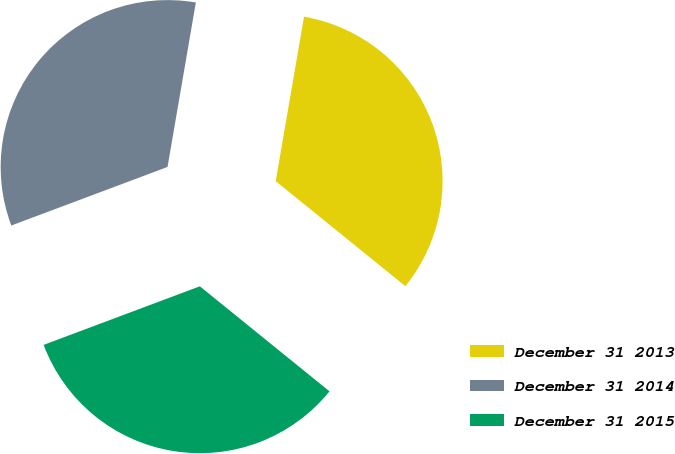Convert chart to OTSL. <chart><loc_0><loc_0><loc_500><loc_500><pie_chart><fcel>December 31 2013<fcel>December 31 2014<fcel>December 31 2015<nl><fcel>33.12%<fcel>33.42%<fcel>33.45%<nl></chart> 